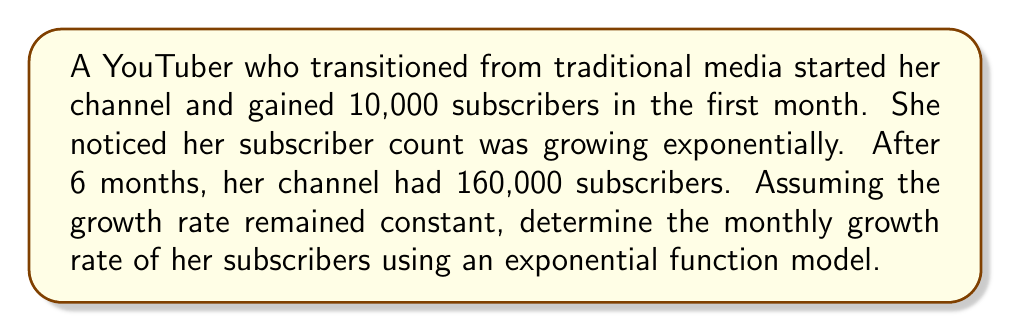Help me with this question. Let's approach this step-by-step using an exponential growth model:

1) The general form of an exponential growth function is:

   $$P(t) = P_0 \cdot (1 + r)^t$$

   Where:
   $P(t)$ is the number of subscribers at time $t$
   $P_0$ is the initial number of subscribers
   $r$ is the monthly growth rate
   $t$ is the number of months

2) We know:
   $P_0 = 10,000$ (initial subscribers)
   $P(6) = 160,000$ (subscribers after 6 months)
   $t = 6$ (months)

3) Let's plug these values into our equation:

   $$160,000 = 10,000 \cdot (1 + r)^6$$

4) Divide both sides by 10,000:

   $$16 = (1 + r)^6$$

5) Take the 6th root of both sides:

   $$\sqrt[6]{16} = 1 + r$$

6) Simplify:

   $$16^{\frac{1}{6}} = 1 + r$$

7) Subtract 1 from both sides:

   $$16^{\frac{1}{6}} - 1 = r$$

8) Calculate the value (you can use a calculator for this):

   $$r \approx 0.2599 \text{ or } 25.99\%$$

This means the channel's subscriber count grew by approximately 26% each month.
Answer: The monthly growth rate of subscribers is approximately 25.99% or 0.2599. 